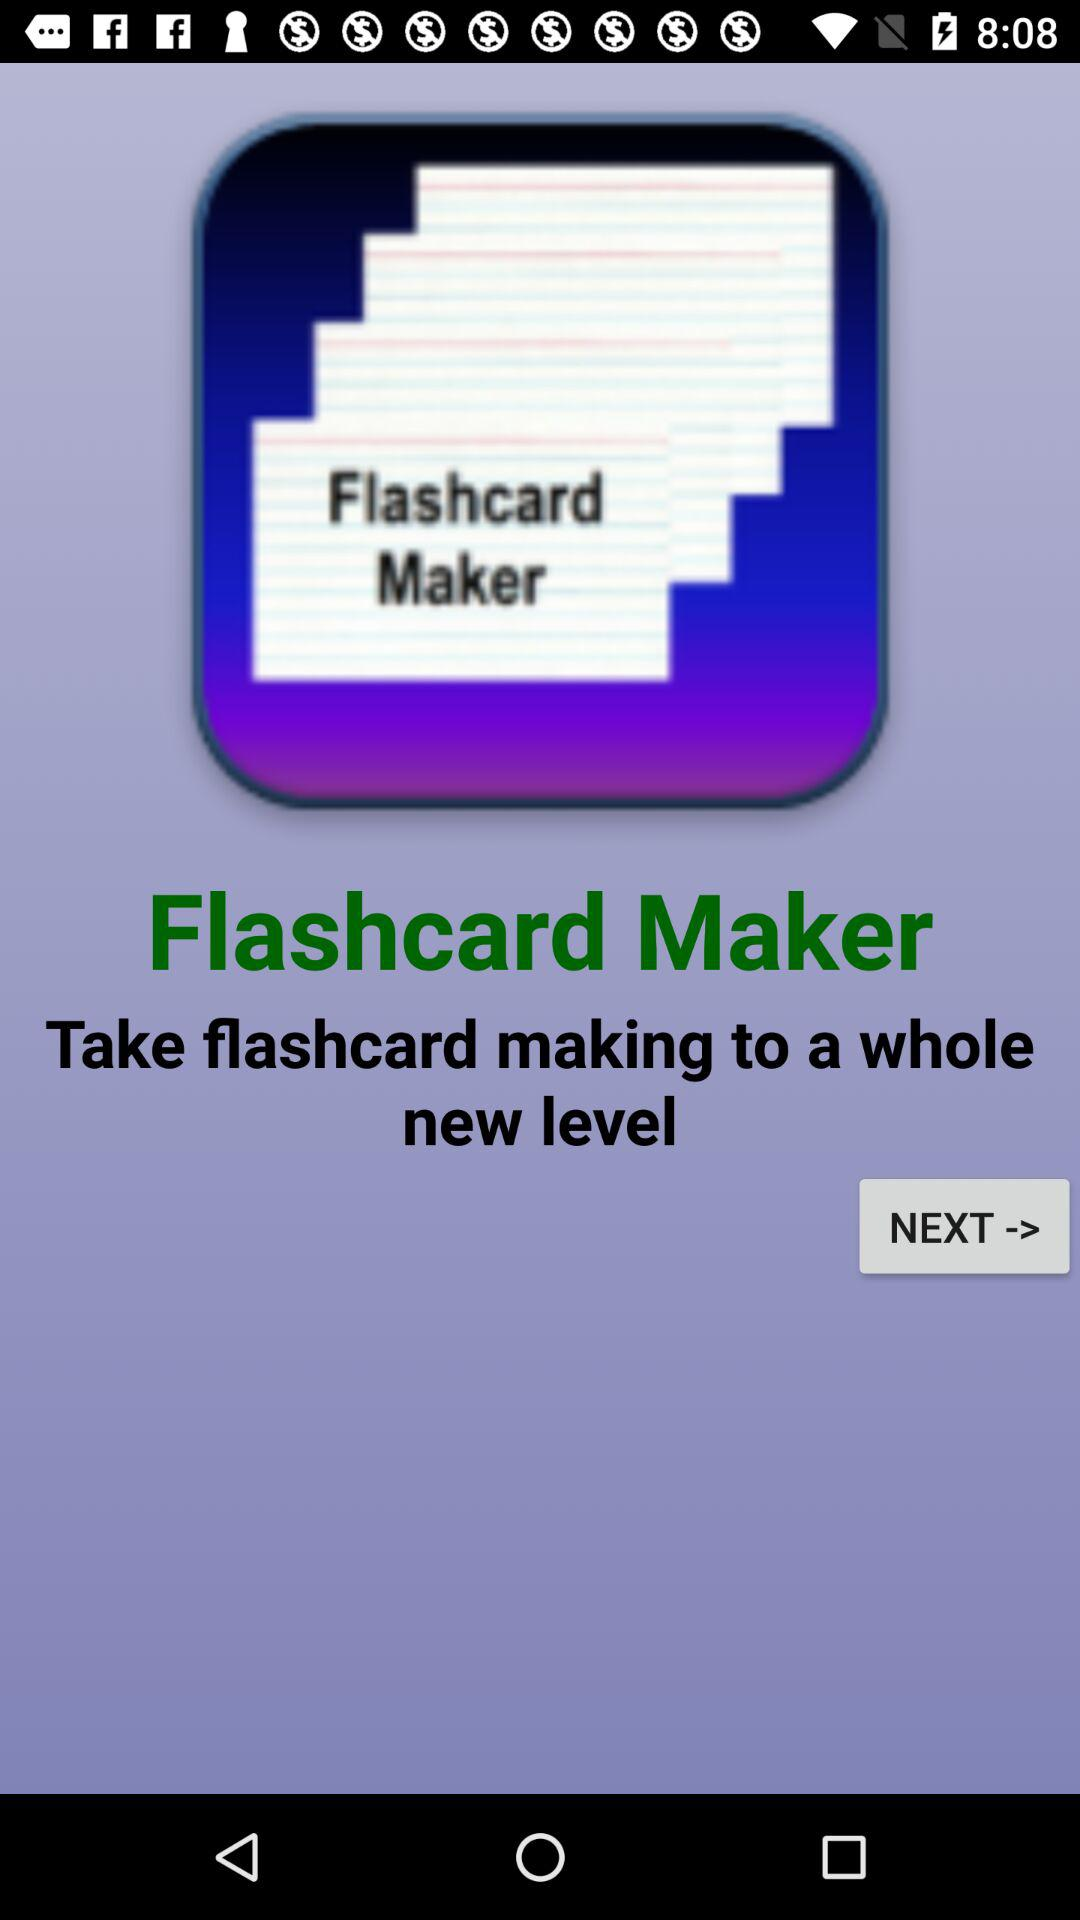What is the name of the application? The name of the application is "Flashcard Maker". 